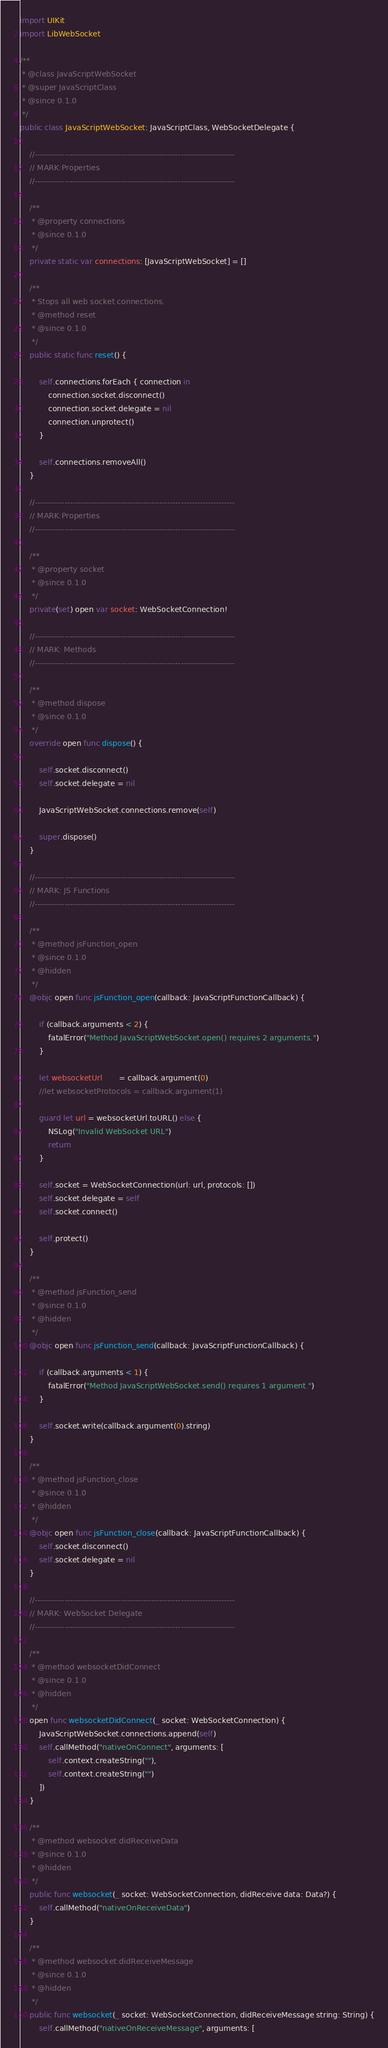<code> <loc_0><loc_0><loc_500><loc_500><_Swift_>import UIKit
import LibWebSocket

/**
 * @class JavaScriptWebSocket
 * @super JavaScriptClass
 * @since 0.1.0
 */
public class JavaScriptWebSocket: JavaScriptClass, WebSocketDelegate {

	//--------------------------------------------------------------------------
	// MARK:Properties
	//--------------------------------------------------------------------------

	/**
	 * @property connections
	 * @since 0.1.0
	 */
	private static var connections: [JavaScriptWebSocket] = []

	/**
	 * Stops all web socket connections.
	 * @method reset
	 * @since 0.1.0
	 */
	public static func reset() {

		self.connections.forEach { connection in
			connection.socket.disconnect()
			connection.socket.delegate = nil
			connection.unprotect()
		}

		self.connections.removeAll()
	}

	//--------------------------------------------------------------------------
	// MARK:Properties
	//--------------------------------------------------------------------------

	/**
	 * @property socket
	 * @since 0.1.0
	 */
	private(set) open var socket: WebSocketConnection!

	//--------------------------------------------------------------------------
	// MARK: Methods
	//--------------------------------------------------------------------------

	/**
	 * @method dispose
	 * @since 0.1.0
	 */
	override open func dispose() {

		self.socket.disconnect()
		self.socket.delegate = nil

		JavaScriptWebSocket.connections.remove(self)

		super.dispose()
	}

	//--------------------------------------------------------------------------
	// MARK: JS Functions
	//--------------------------------------------------------------------------

	/**
	 * @method jsFunction_open
	 * @since 0.1.0
	 * @hidden
	 */
	@objc open func jsFunction_open(callback: JavaScriptFunctionCallback) {

		if (callback.arguments < 2) {
			fatalError("Method JavaScriptWebSocket.open() requires 2 arguments.")
		}

		let websocketUrl       = callback.argument(0)
		//let websocketProtocols = callback.argument(1)

		guard let url = websocketUrl.toURL() else {
			NSLog("Invalid WebSocket URL")
			return
		}

		self.socket = WebSocketConnection(url: url, protocols: [])
		self.socket.delegate = self
		self.socket.connect()

		self.protect()
	}

	/**
	 * @method jsFunction_send
	 * @since 0.1.0
	 * @hidden
	 */
	@objc open func jsFunction_send(callback: JavaScriptFunctionCallback) {

		if (callback.arguments < 1) {
			fatalError("Method JavaScriptWebSocket.send() requires 1 argument.")
		}

		self.socket.write(callback.argument(0).string)
	}

	/**
	 * @method jsFunction_close
	 * @since 0.1.0
	 * @hidden
	 */
	@objc open func jsFunction_close(callback: JavaScriptFunctionCallback) {
		self.socket.disconnect()
		self.socket.delegate = nil
	}

	//--------------------------------------------------------------------------
	// MARK: WebSocket Delegate
	//--------------------------------------------------------------------------

	/**
	 * @method websocketDidConnect
	 * @since 0.1.0
	 * @hidden
	 */
	open func websocketDidConnect(_ socket: WebSocketConnection) {
		JavaScriptWebSocket.connections.append(self)
		self.callMethod("nativeOnConnect", arguments: [
			self.context.createString(""),
			self.context.createString("")
		])
	}

	/**
	 * @method websocket:didReceiveData
	 * @since 0.1.0
	 * @hidden
	 */
	public func websocket(_ socket: WebSocketConnection, didReceive data: Data?) {
		self.callMethod("nativeOnReceiveData")
	}

	/**
	 * @method websocket:didReceiveMessage
	 * @since 0.1.0
	 * @hidden
	 */
	public func websocket(_ socket: WebSocketConnection, didReceiveMessage string: String) {
		self.callMethod("nativeOnReceiveMessage", arguments: [</code> 